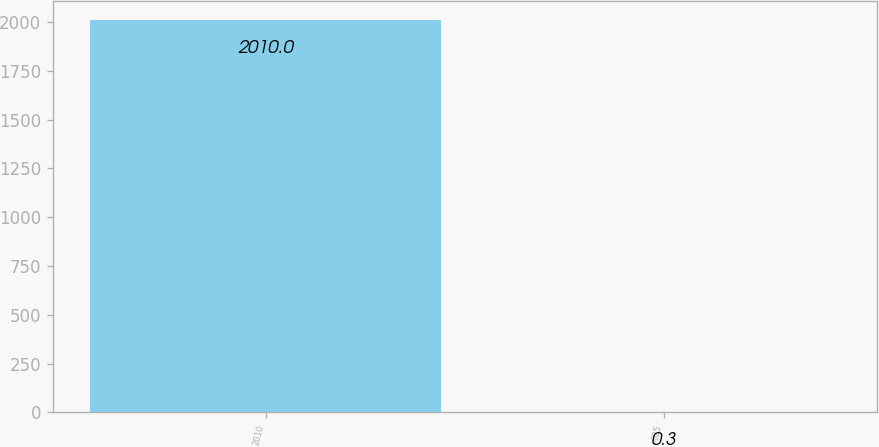<chart> <loc_0><loc_0><loc_500><loc_500><bar_chart><fcel>2010<fcel>025<nl><fcel>2010<fcel>0.3<nl></chart> 